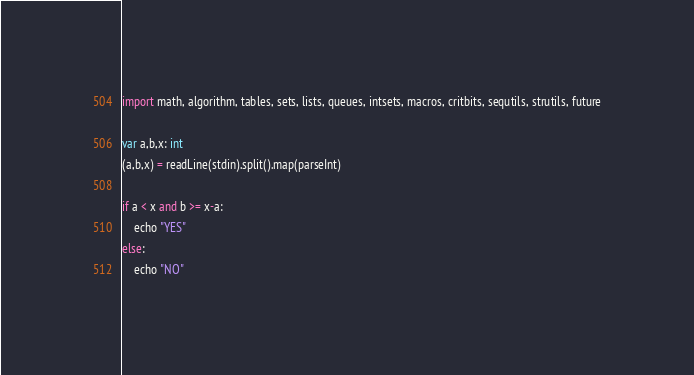Convert code to text. <code><loc_0><loc_0><loc_500><loc_500><_Nim_>import math, algorithm, tables, sets, lists, queues, intsets, macros, critbits, sequtils, strutils, future

var a,b,x: int
(a,b,x) = readLine(stdin).split().map(parseInt)

if a < x and b >= x-a:
    echo "YES"
else:
    echo "NO"    </code> 